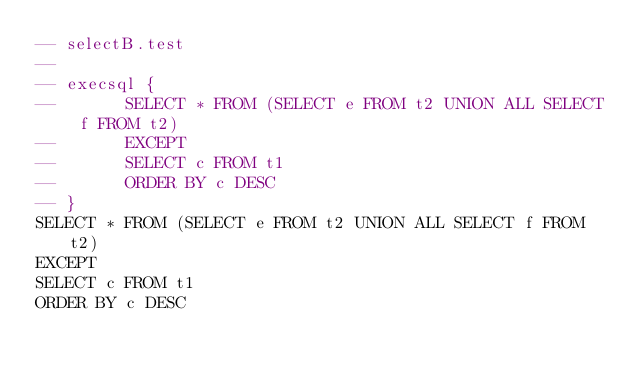Convert code to text. <code><loc_0><loc_0><loc_500><loc_500><_SQL_>-- selectB.test
-- 
-- execsql {
--       SELECT * FROM (SELECT e FROM t2 UNION ALL SELECT f FROM t2)
--       EXCEPT 
--       SELECT c FROM t1
--       ORDER BY c DESC
-- }
SELECT * FROM (SELECT e FROM t2 UNION ALL SELECT f FROM t2)
EXCEPT 
SELECT c FROM t1
ORDER BY c DESC</code> 